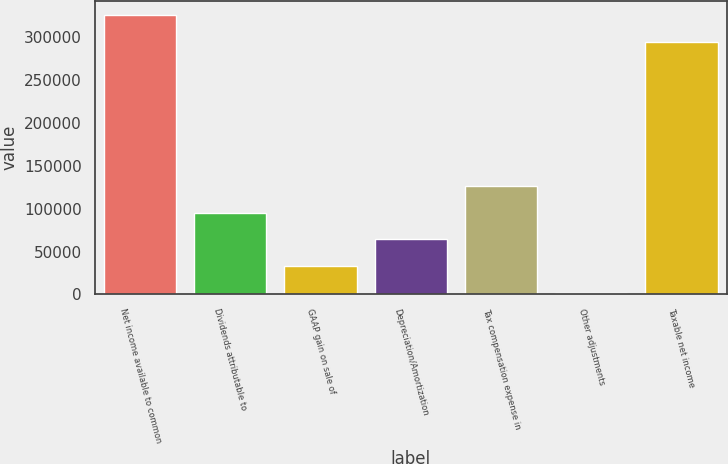Convert chart. <chart><loc_0><loc_0><loc_500><loc_500><bar_chart><fcel>Net income available to common<fcel>Dividends attributable to<fcel>GAAP gain on sale of<fcel>Depreciation/Amortization<fcel>Tax compensation expense in<fcel>Other adjustments<fcel>Taxable net income<nl><fcel>326211<fcel>95518.1<fcel>33186.7<fcel>64352.4<fcel>126684<fcel>2021<fcel>295045<nl></chart> 